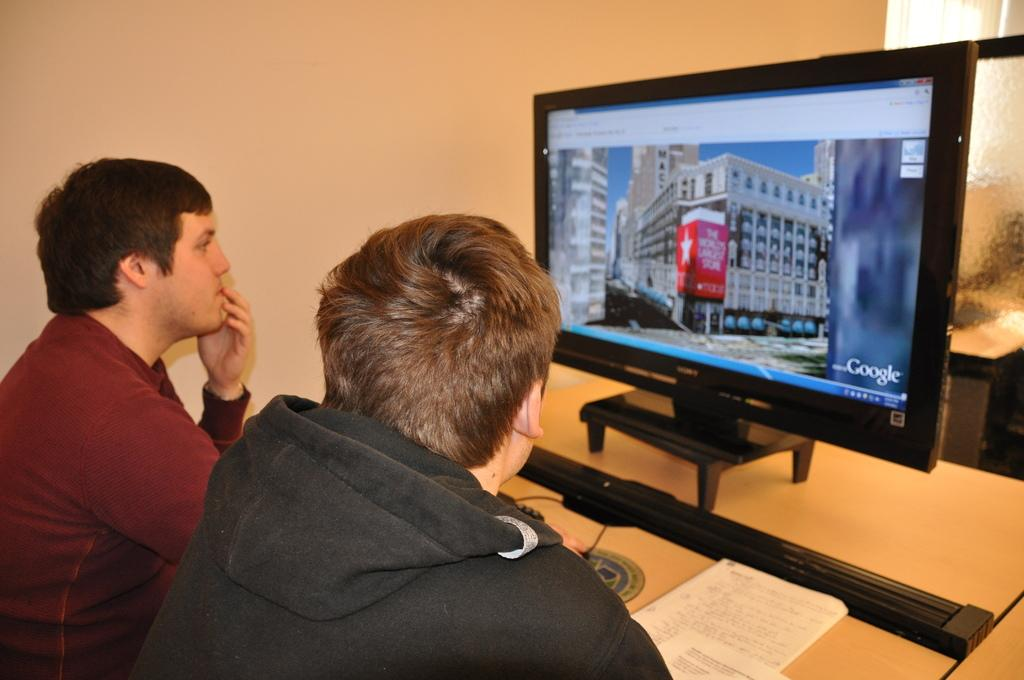<image>
Present a compact description of the photo's key features. a screen with Google on the side of it 